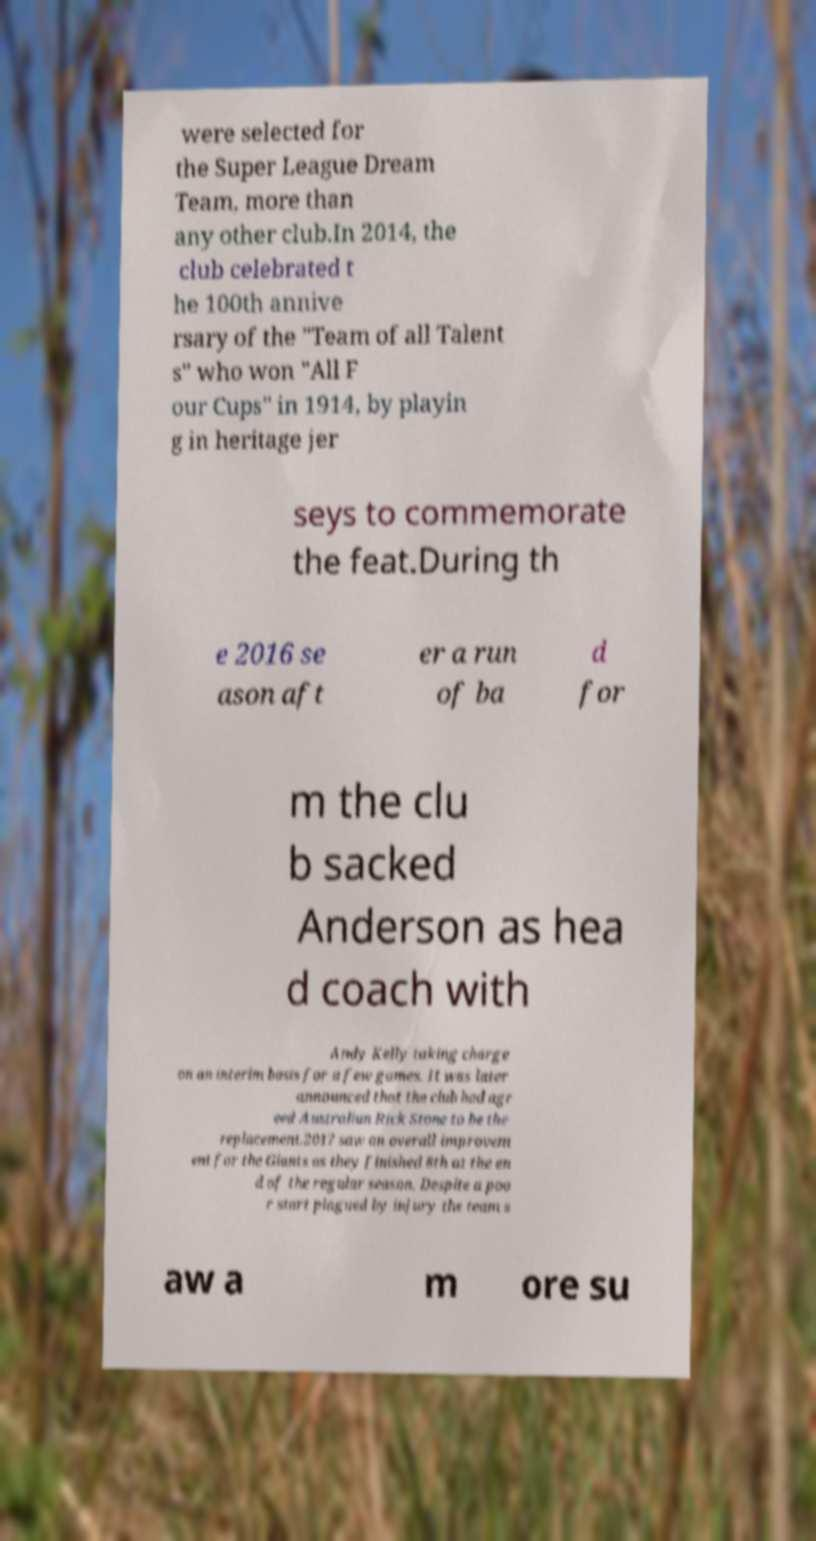For documentation purposes, I need the text within this image transcribed. Could you provide that? were selected for the Super League Dream Team, more than any other club.In 2014, the club celebrated t he 100th annive rsary of the "Team of all Talent s" who won "All F our Cups" in 1914, by playin g in heritage jer seys to commemorate the feat.During th e 2016 se ason aft er a run of ba d for m the clu b sacked Anderson as hea d coach with Andy Kelly taking charge on an interim basis for a few games. It was later announced that the club had agr eed Australian Rick Stone to be the replacement.2017 saw an overall improvem ent for the Giants as they finished 8th at the en d of the regular season. Despite a poo r start plagued by injury the team s aw a m ore su 